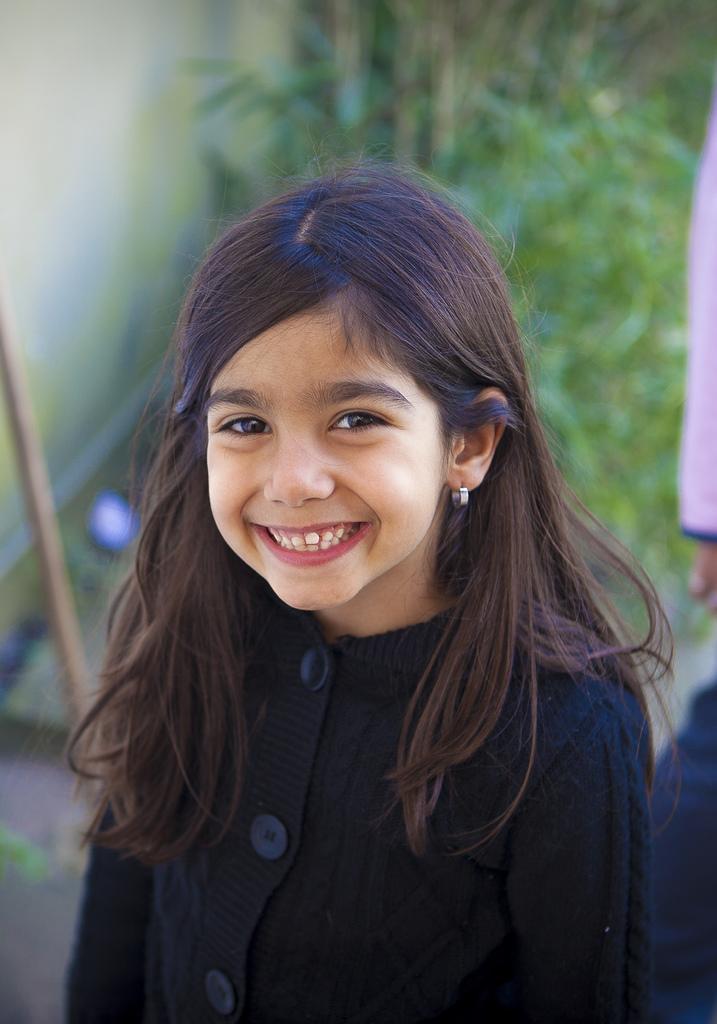Describe this image in one or two sentences. In this image we can see one girl standing and laughing. There is one wooden stick near to the wall, some objects on the surface, backside of the girl one person hand and leg is there. There are some plants and grass on the surface. 